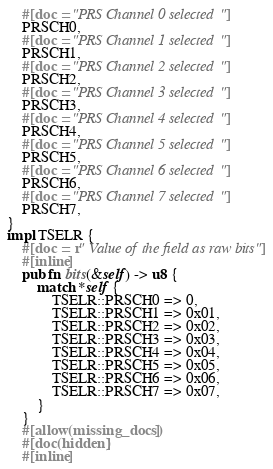<code> <loc_0><loc_0><loc_500><loc_500><_Rust_>    #[doc = "PRS Channel 0 selected"]
    PRSCH0,
    #[doc = "PRS Channel 1 selected"]
    PRSCH1,
    #[doc = "PRS Channel 2 selected"]
    PRSCH2,
    #[doc = "PRS Channel 3 selected"]
    PRSCH3,
    #[doc = "PRS Channel 4 selected"]
    PRSCH4,
    #[doc = "PRS Channel 5 selected"]
    PRSCH5,
    #[doc = "PRS Channel 6 selected"]
    PRSCH6,
    #[doc = "PRS Channel 7 selected"]
    PRSCH7,
}
impl TSELR {
    #[doc = r" Value of the field as raw bits"]
    #[inline]
    pub fn bits(&self) -> u8 {
        match *self {
            TSELR::PRSCH0 => 0,
            TSELR::PRSCH1 => 0x01,
            TSELR::PRSCH2 => 0x02,
            TSELR::PRSCH3 => 0x03,
            TSELR::PRSCH4 => 0x04,
            TSELR::PRSCH5 => 0x05,
            TSELR::PRSCH6 => 0x06,
            TSELR::PRSCH7 => 0x07,
        }
    }
    #[allow(missing_docs)]
    #[doc(hidden)]
    #[inline]</code> 